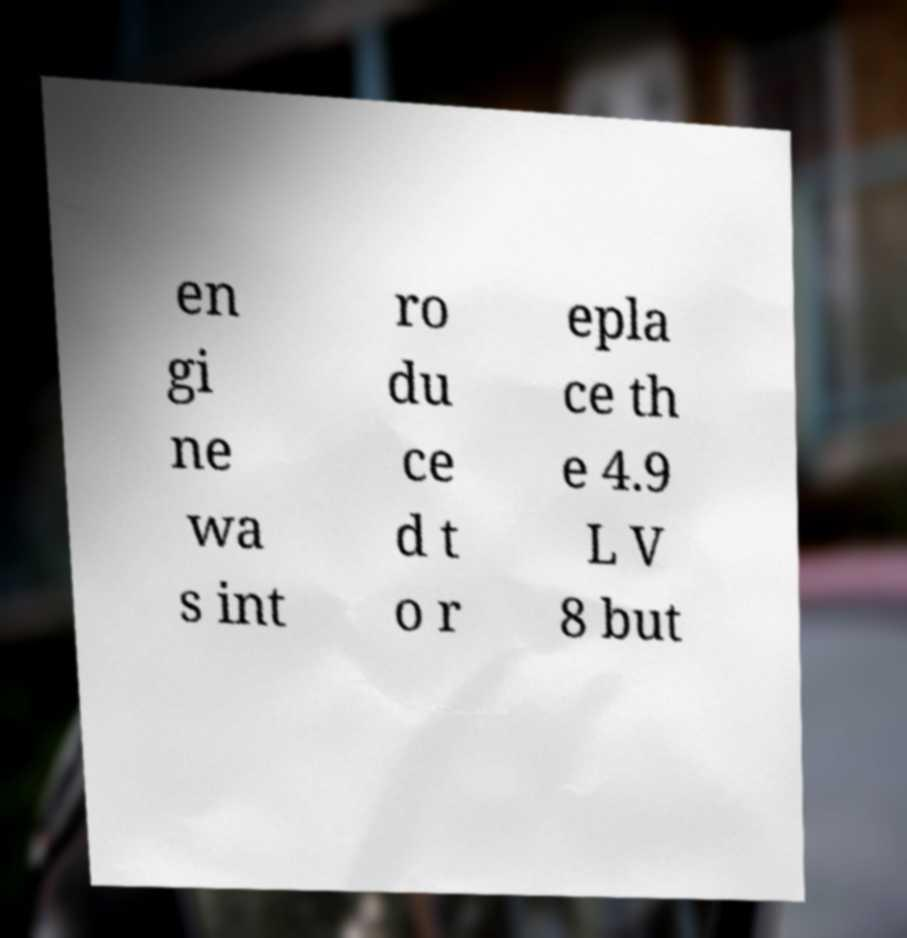Can you accurately transcribe the text from the provided image for me? en gi ne wa s int ro du ce d t o r epla ce th e 4.9 L V 8 but 